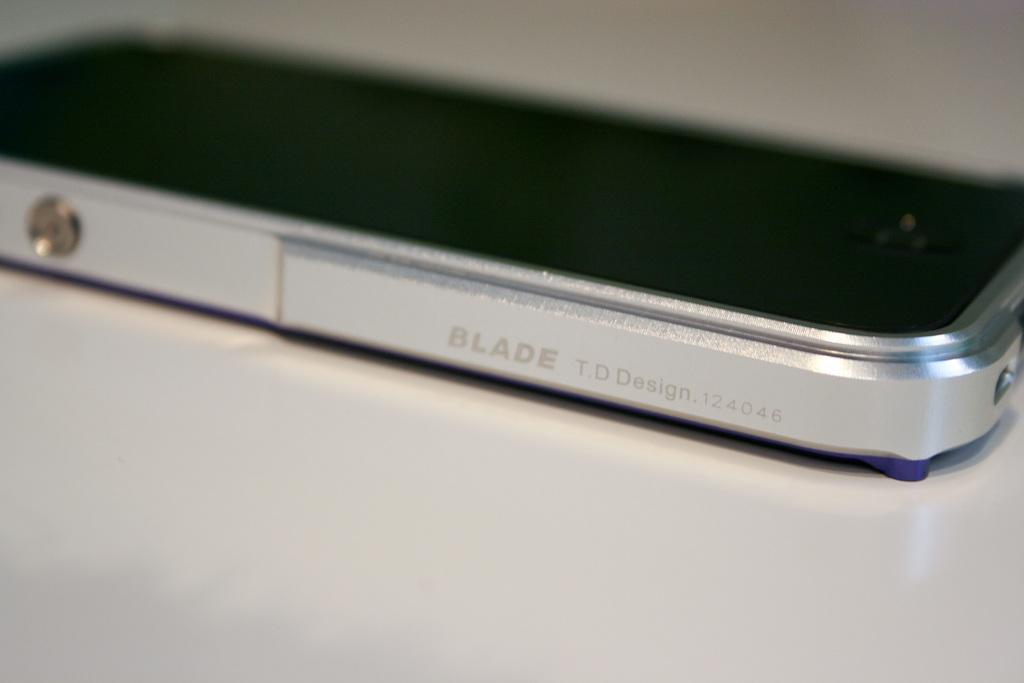This a blade design mobile?
Keep it short and to the point. Yes. 